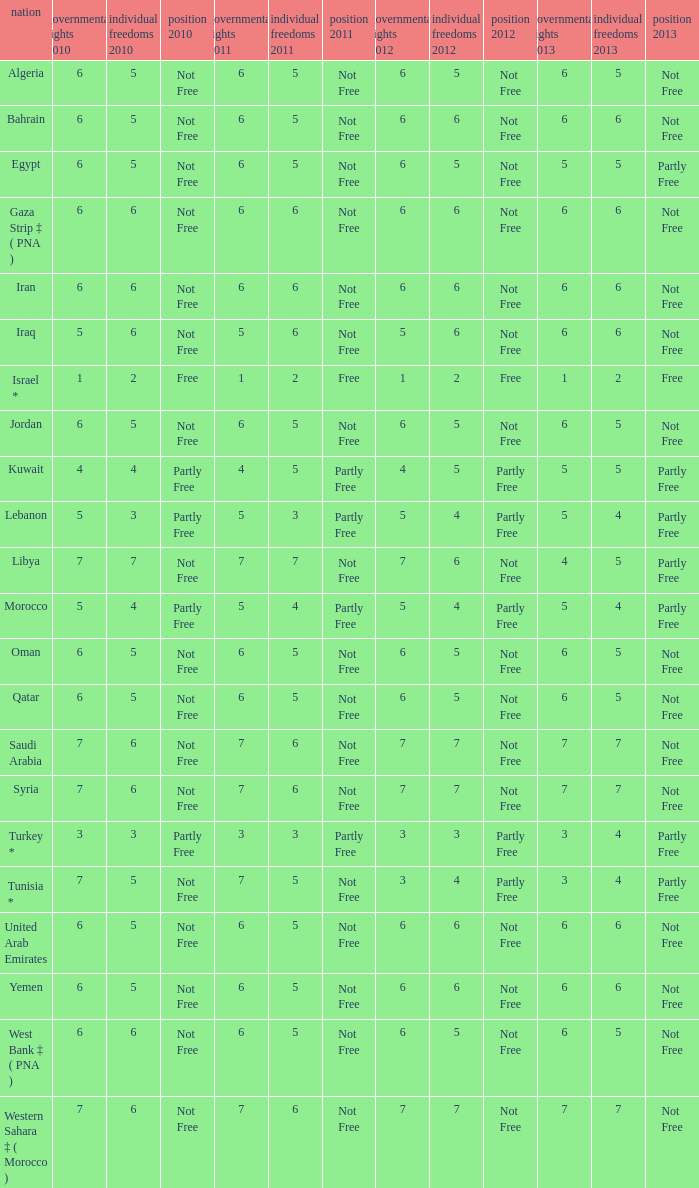How many civil liberties 2013 values are associated with a 2010 political rights value of 6, civil liberties 2012 values over 5, and political rights 2011 under 6? 0.0. 